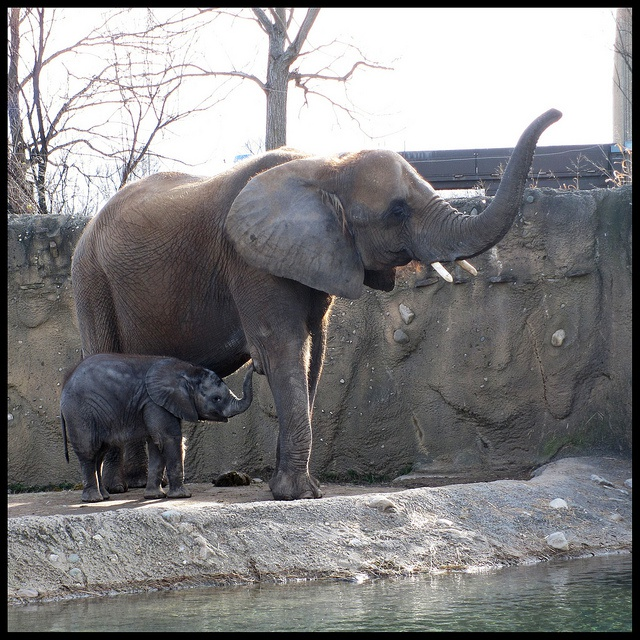Describe the objects in this image and their specific colors. I can see elephant in black, gray, and darkgray tones and elephant in black and gray tones in this image. 